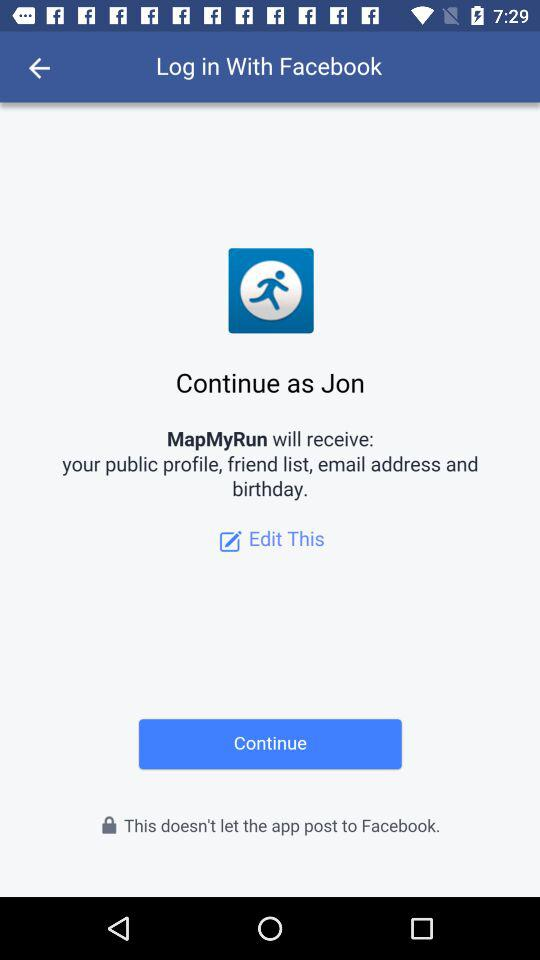What application is asking for permission? The application "MapMyRun" is asking for permission. 